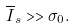Convert formula to latex. <formula><loc_0><loc_0><loc_500><loc_500>\overline { I } _ { s } > > \sigma _ { 0 } .</formula> 